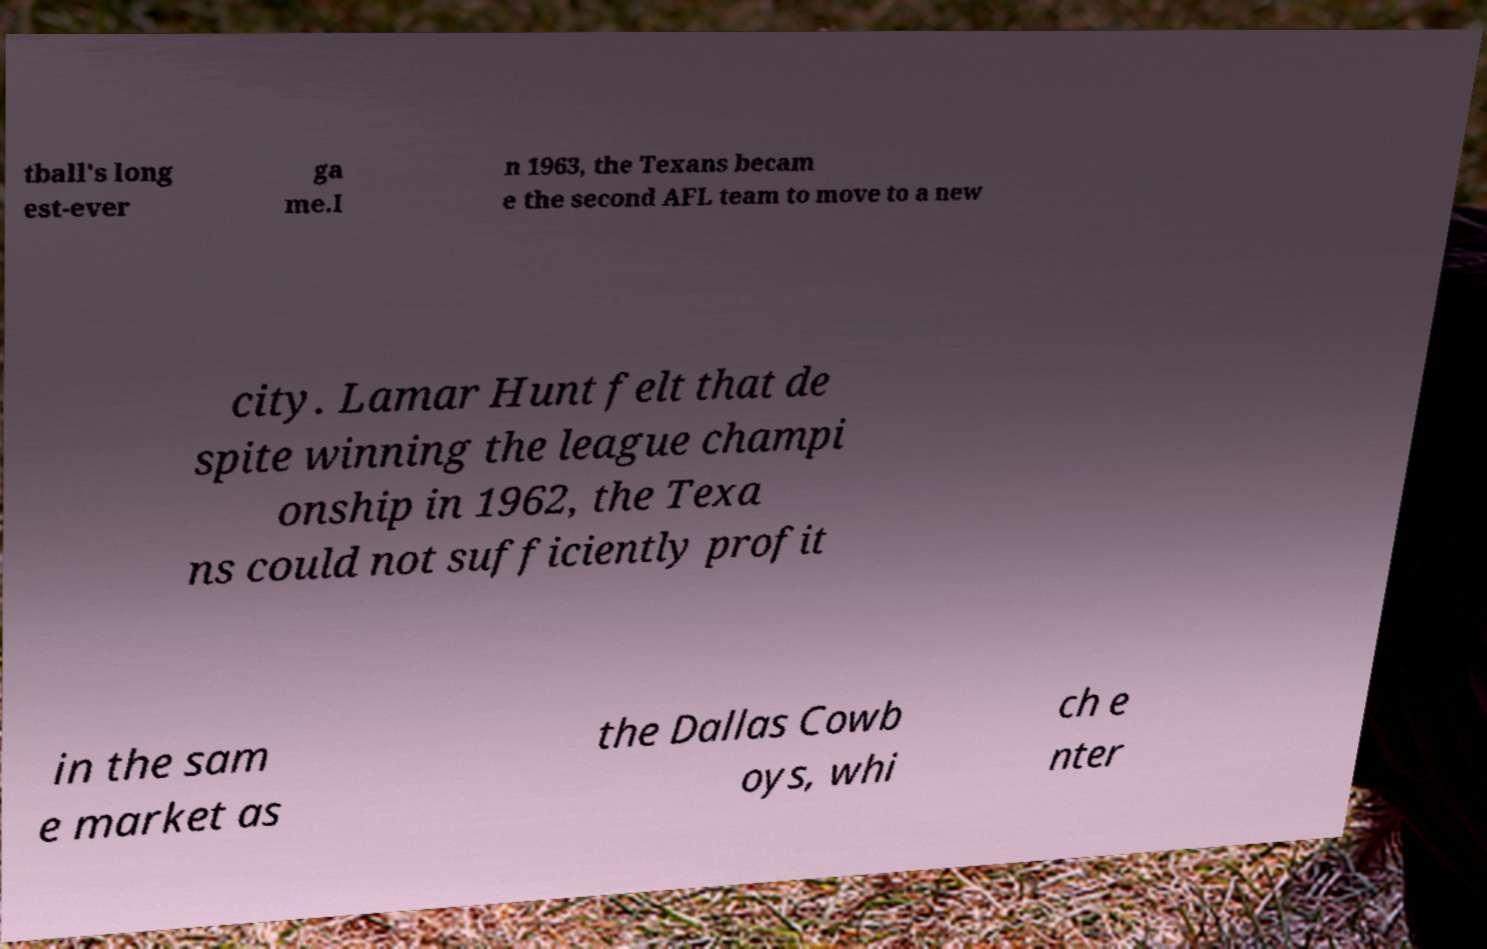There's text embedded in this image that I need extracted. Can you transcribe it verbatim? tball's long est-ever ga me.I n 1963, the Texans becam e the second AFL team to move to a new city. Lamar Hunt felt that de spite winning the league champi onship in 1962, the Texa ns could not sufficiently profit in the sam e market as the Dallas Cowb oys, whi ch e nter 